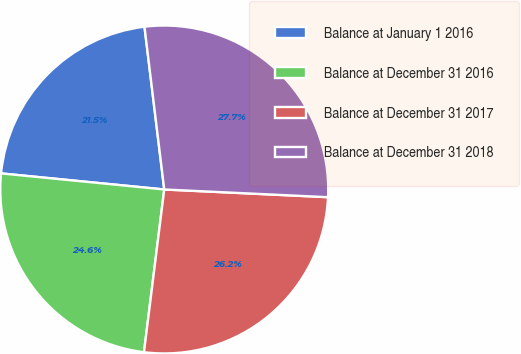Convert chart. <chart><loc_0><loc_0><loc_500><loc_500><pie_chart><fcel>Balance at January 1 2016<fcel>Balance at December 31 2016<fcel>Balance at December 31 2017<fcel>Balance at December 31 2018<nl><fcel>21.51%<fcel>24.59%<fcel>26.22%<fcel>27.67%<nl></chart> 